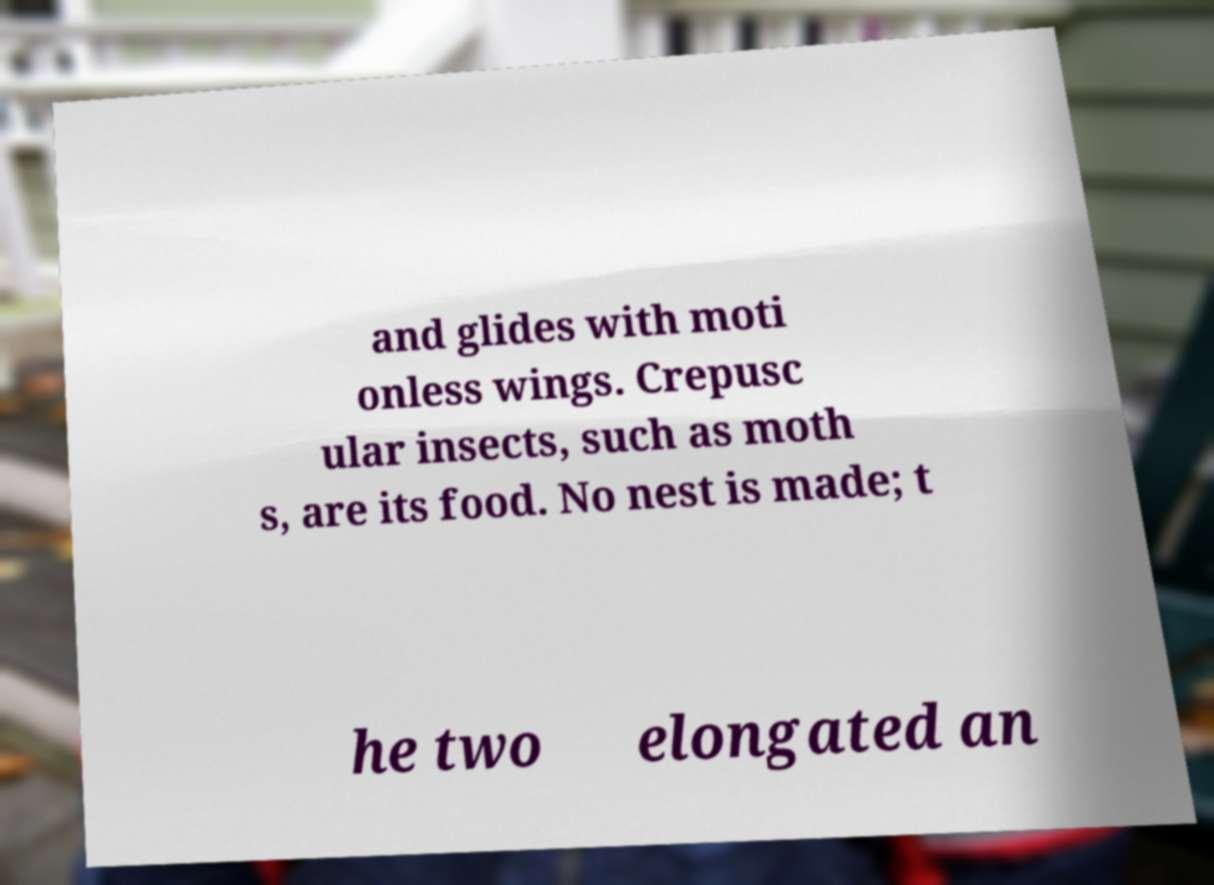Please read and relay the text visible in this image. What does it say? and glides with moti onless wings. Crepusc ular insects, such as moth s, are its food. No nest is made; t he two elongated an 